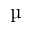Convert formula to latex. <formula><loc_0><loc_0><loc_500><loc_500>\text  mu</formula> 